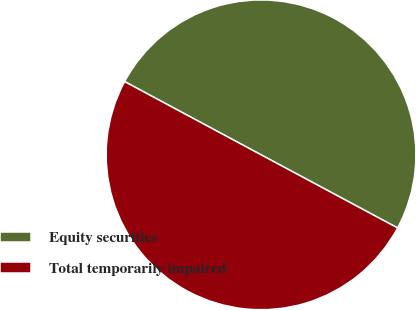<chart> <loc_0><loc_0><loc_500><loc_500><pie_chart><fcel>Equity securities<fcel>Total temporarily impaired<nl><fcel>49.99%<fcel>50.01%<nl></chart> 